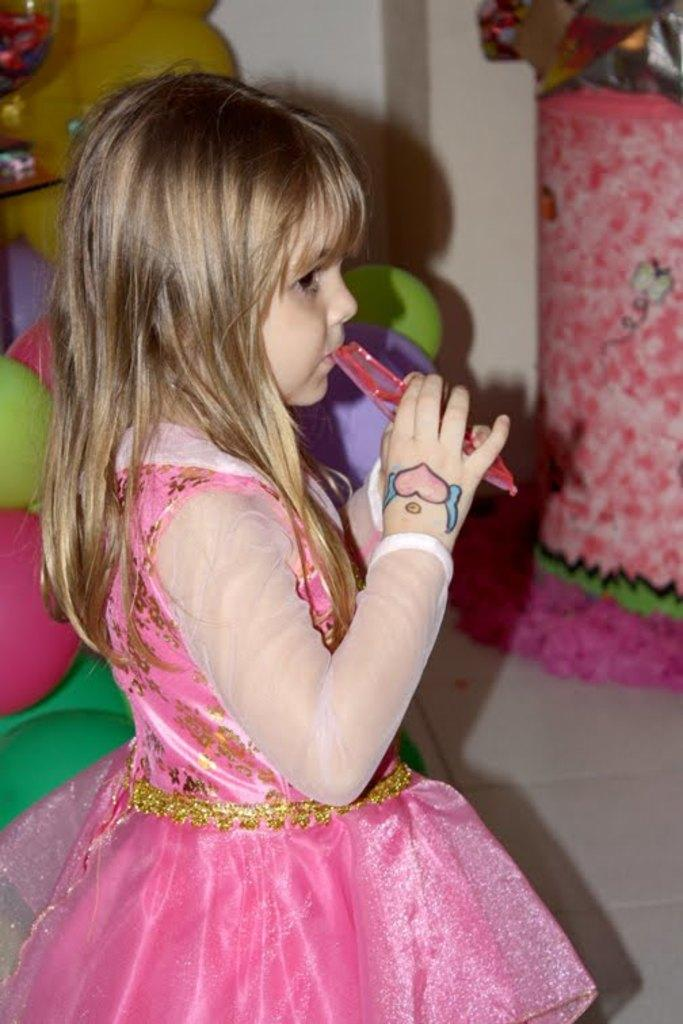What is the main subject of the image? There is a girl standing in the image. Can you describe the girl's attire? The girl is wearing a pink dress. Are there any unique features about the girl? Yes, the girl has a tattoo on her hand. What can be seen in the background of the image? There are toys in the backdrop of the image. What is the setting of the image? There is a wall in the image. Can you tell me how many cats are sitting on the quilt in the image? There is no quilt or cats present in the image. 